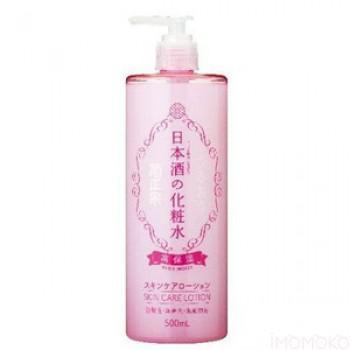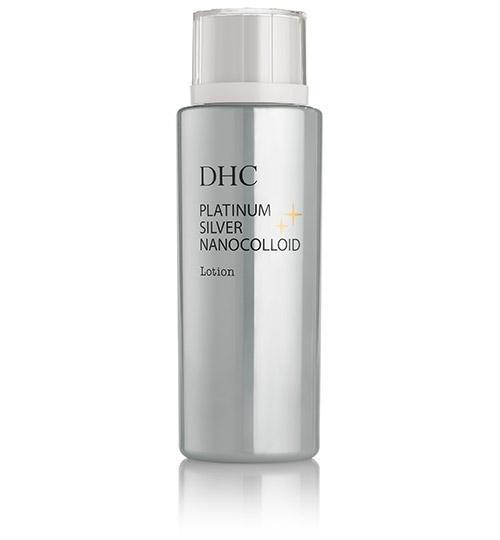The first image is the image on the left, the second image is the image on the right. For the images shown, is this caption "The product on the left is in a pump-top bottle with its nozzle turned leftward, and the product on the right does not have a pump-top." true? Answer yes or no. Yes. The first image is the image on the left, the second image is the image on the right. For the images shown, is this caption "The container in the image on the left has a pump nozzle." true? Answer yes or no. Yes. 